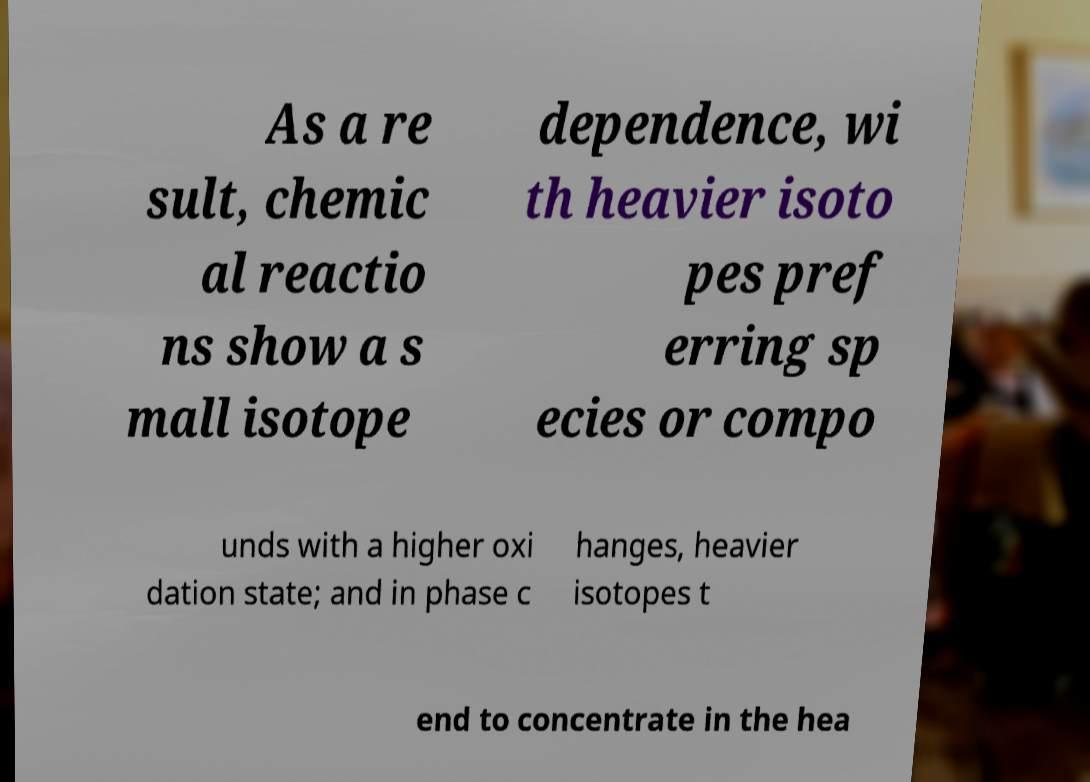Could you assist in decoding the text presented in this image and type it out clearly? As a re sult, chemic al reactio ns show a s mall isotope dependence, wi th heavier isoto pes pref erring sp ecies or compo unds with a higher oxi dation state; and in phase c hanges, heavier isotopes t end to concentrate in the hea 